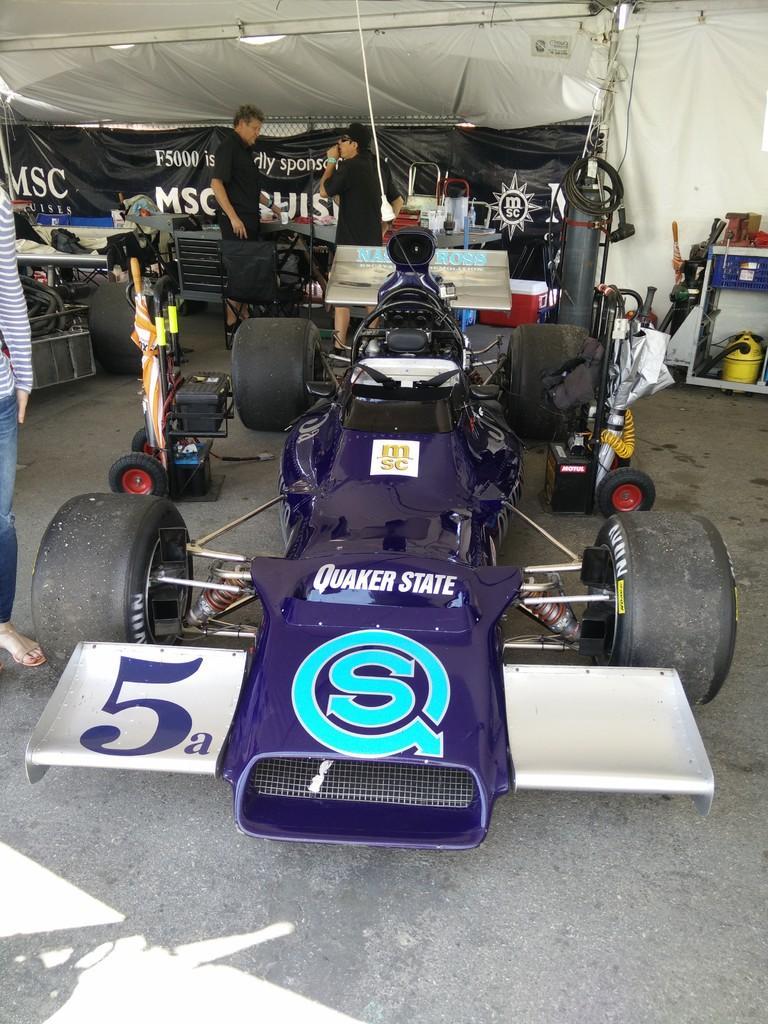Describe this image in one or two sentences. In this picture, we can see a few people, a vehicle on the ground, we can see some objects on the ground like tables, cylinder, and we can see some objects on the table like spare parts, boxes, and in the background we can see a cloth with pole, and we can see a poster with some text on it. 